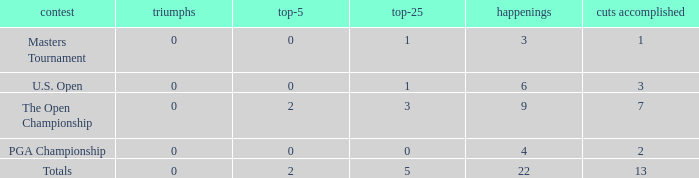What is the average number of cuts made for events with 0 top-5s? None. 